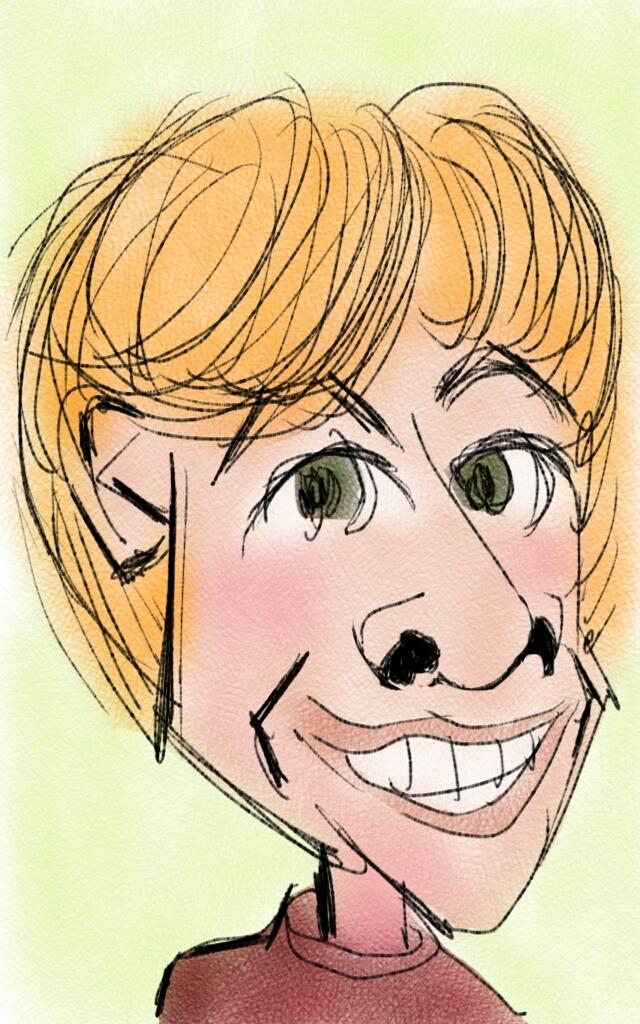What type of image is depicted in the picture? There is a cartoon picture of a person in the image. Can you see a toothbrush being used at the seashore in the image? There is no toothbrush or seashore present in the image; it features a cartoon picture of a person. 